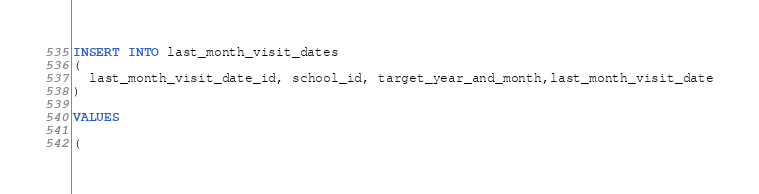Convert code to text. <code><loc_0><loc_0><loc_500><loc_500><_SQL_>INSERT INTO last_month_visit_dates
(
  last_month_visit_date_id, school_id, target_year_and_month,last_month_visit_date
)

VALUES

(</code> 